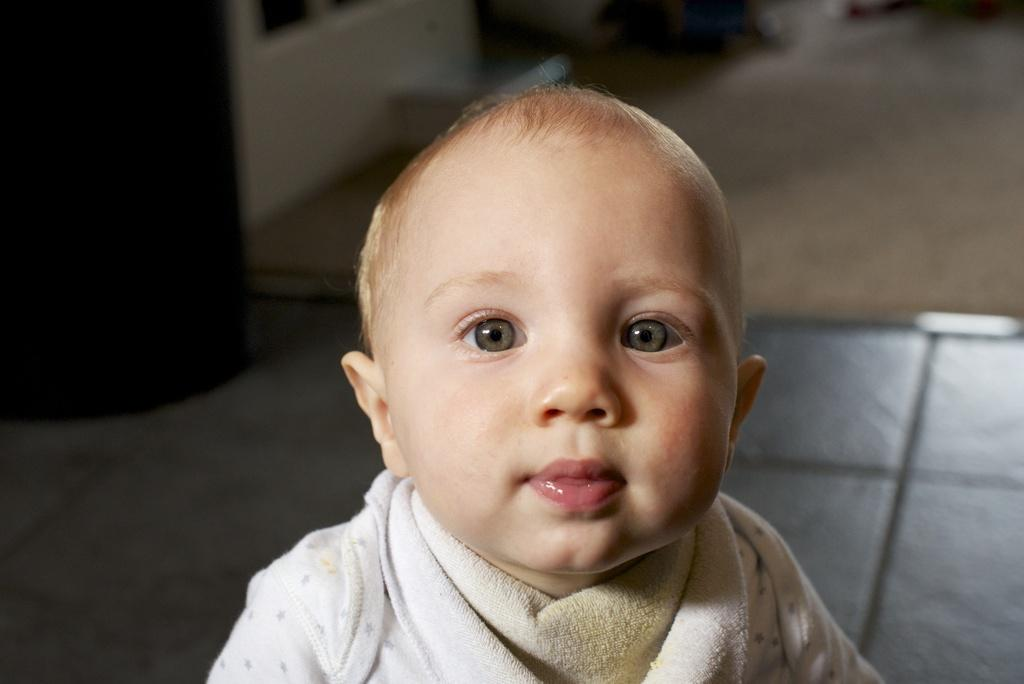What is the main subject of the image? There is a baby in the image. Can you describe the background of the image? The background of the image is blurred. How many times does the baby sneeze in the image? There is no indication of the baby sneezing in the image. What type of house is visible in the background of the image? There is no house visible in the image; the background is blurred. 